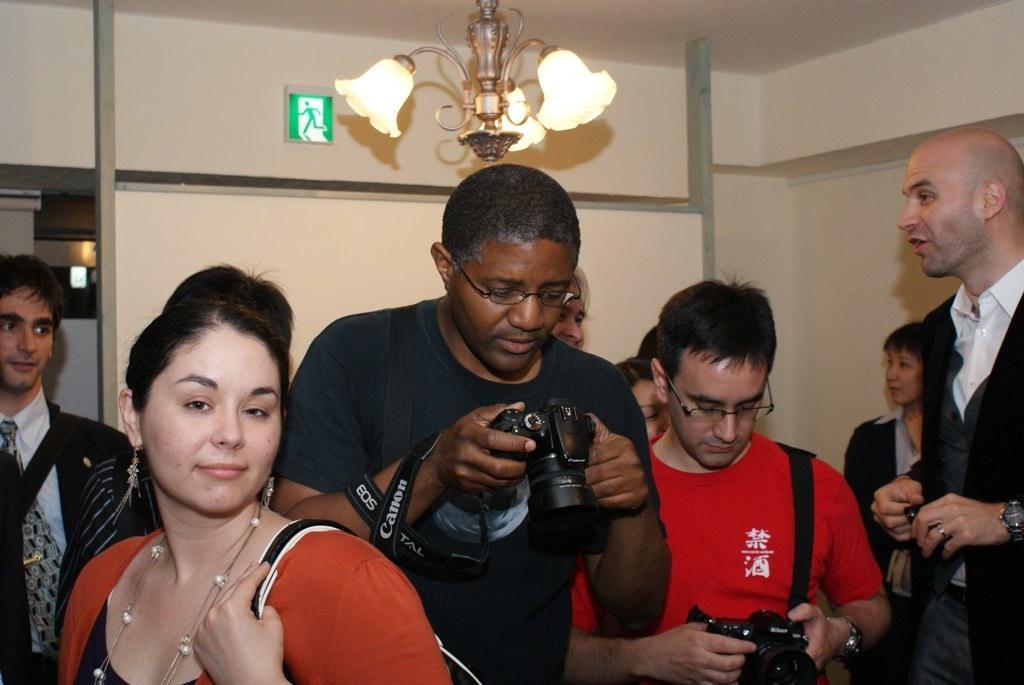Describe this image in one or two sentences. There are many people. Some are wearing specs and holding bags and camera. In the back there is a wall. On the wall there is a sign board. Also there is a chandelier. 